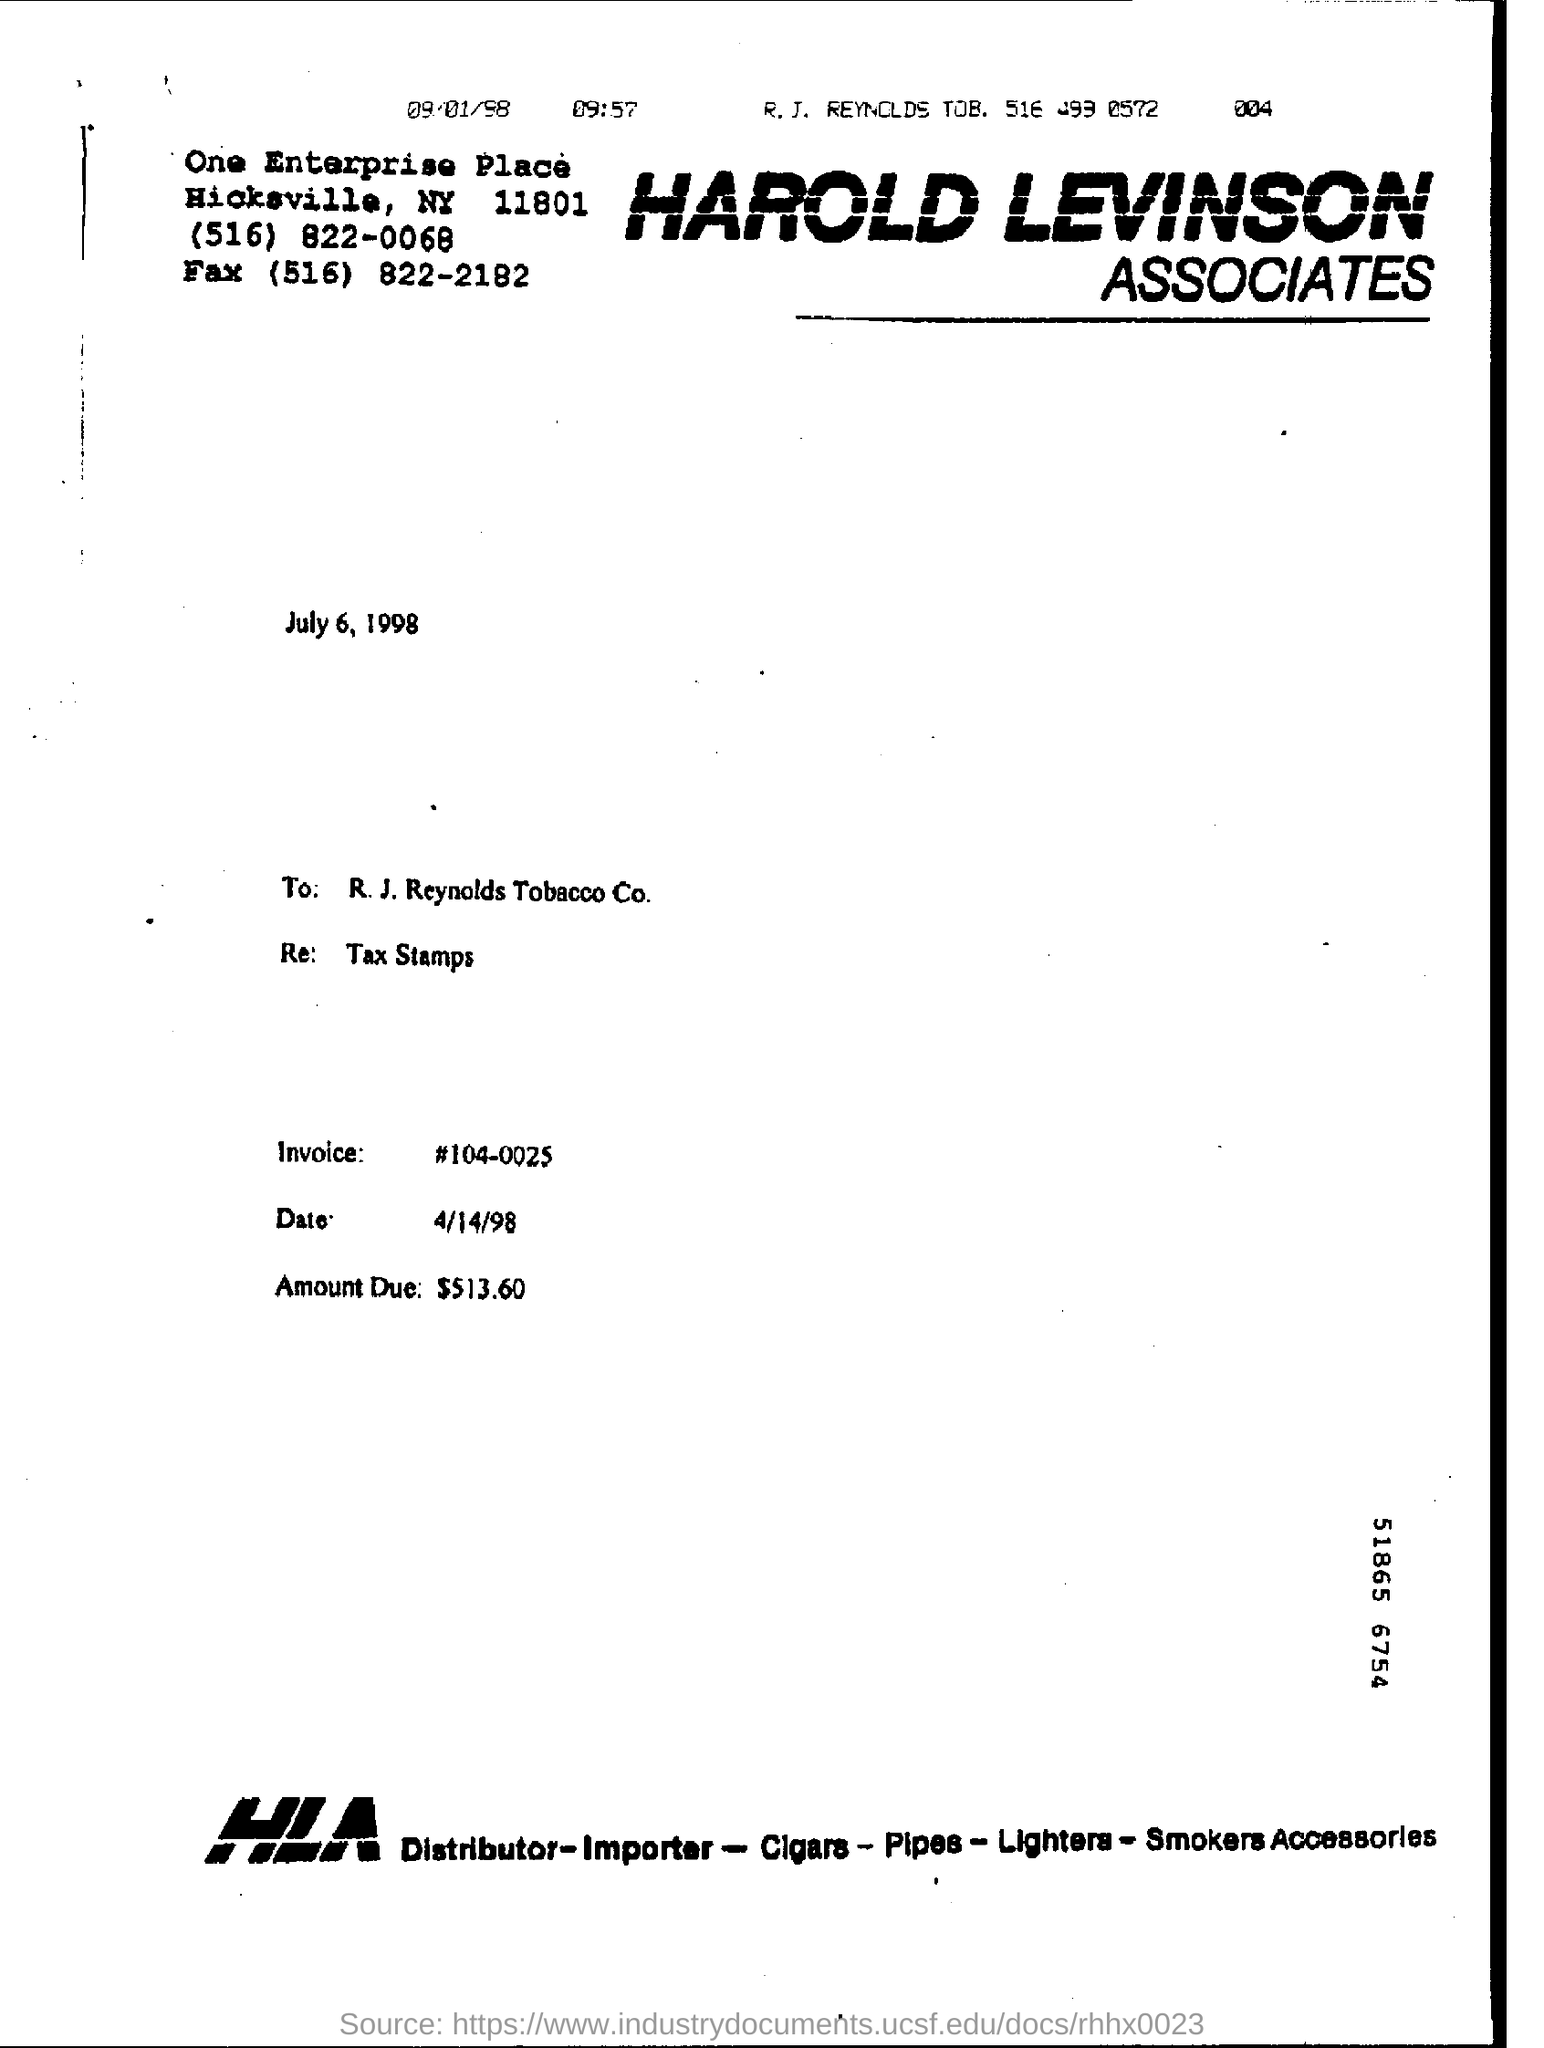What is the amount due  to be paid ?
Give a very brief answer. $513.60. What is head line of this document?
Provide a short and direct response. Harold Levinson Associates. What is the name of the company in the letter head?
Your answer should be compact. HAROLD LEVINSON ASSOCIATES. What is the date mentioned below the letter head ?
Your response must be concise. July 6, 1998. Who is receiver of the letter?
Provide a short and direct response. R.J Reynolds Tobacco Co. What is the invoice no:?
Give a very brief answer. 104-0025. What is the invoice date?
Ensure brevity in your answer.  4/14/98. What is the amount due?
Give a very brief answer. $ 513.60. 